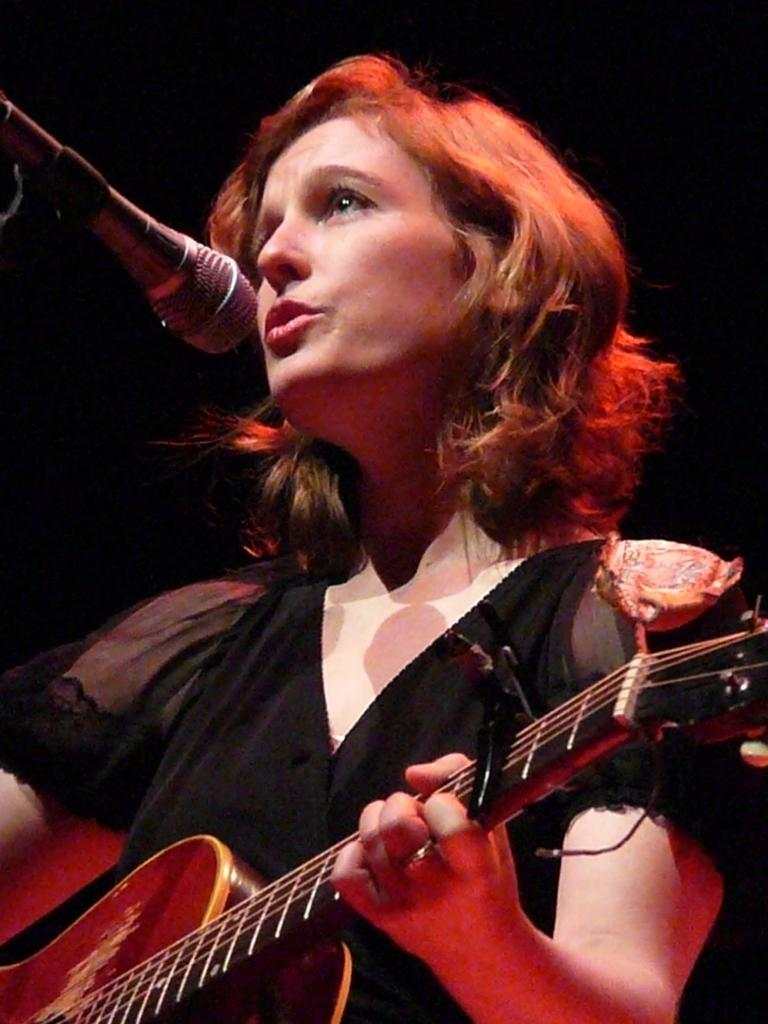Who is the main subject in the image? There is a woman in the image. What is the woman doing in the image? The woman is playing a guitar and singing. What object is in front of the woman? There is a microphone in front of the woman. Can you hear the rhythm of the ocean in the background of the image? There is no ocean or any background sound present in the image; it only shows a woman playing a guitar and singing. 